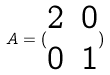<formula> <loc_0><loc_0><loc_500><loc_500>A = ( \begin{matrix} 2 & 0 \\ 0 & 1 \end{matrix} )</formula> 